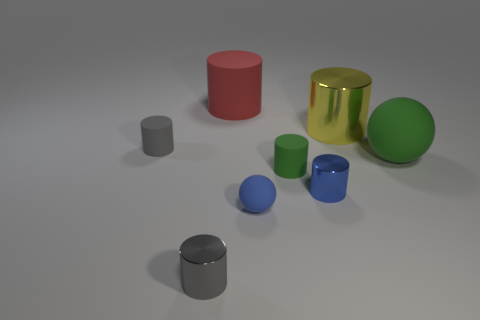Subtract all blue cylinders. How many cylinders are left? 5 Subtract all tiny blue metallic cylinders. How many cylinders are left? 5 Subtract 3 cylinders. How many cylinders are left? 3 Subtract all blue cylinders. Subtract all purple balls. How many cylinders are left? 5 Add 1 tiny blue rubber spheres. How many objects exist? 9 Subtract all cylinders. How many objects are left? 2 Add 6 big yellow metallic objects. How many big yellow metallic objects are left? 7 Add 3 green metallic cylinders. How many green metallic cylinders exist? 3 Subtract 1 green spheres. How many objects are left? 7 Subtract all red matte objects. Subtract all gray metallic cylinders. How many objects are left? 6 